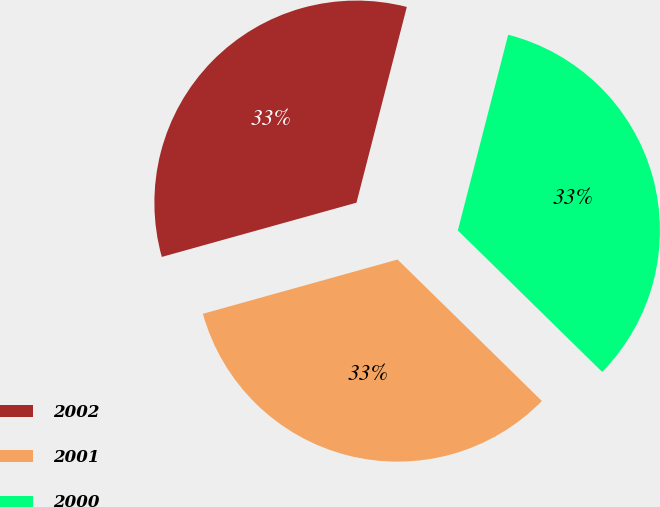<chart> <loc_0><loc_0><loc_500><loc_500><pie_chart><fcel>2002<fcel>2001<fcel>2000<nl><fcel>33.33%<fcel>33.33%<fcel>33.33%<nl></chart> 